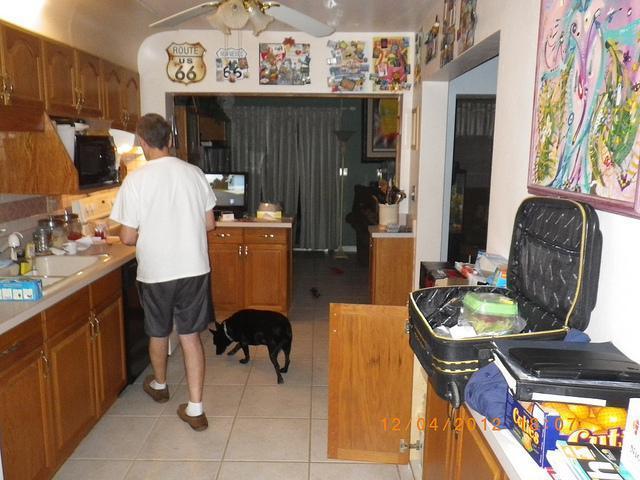How many sinks can be seen?
Give a very brief answer. 1. How many people are there?
Give a very brief answer. 2. 